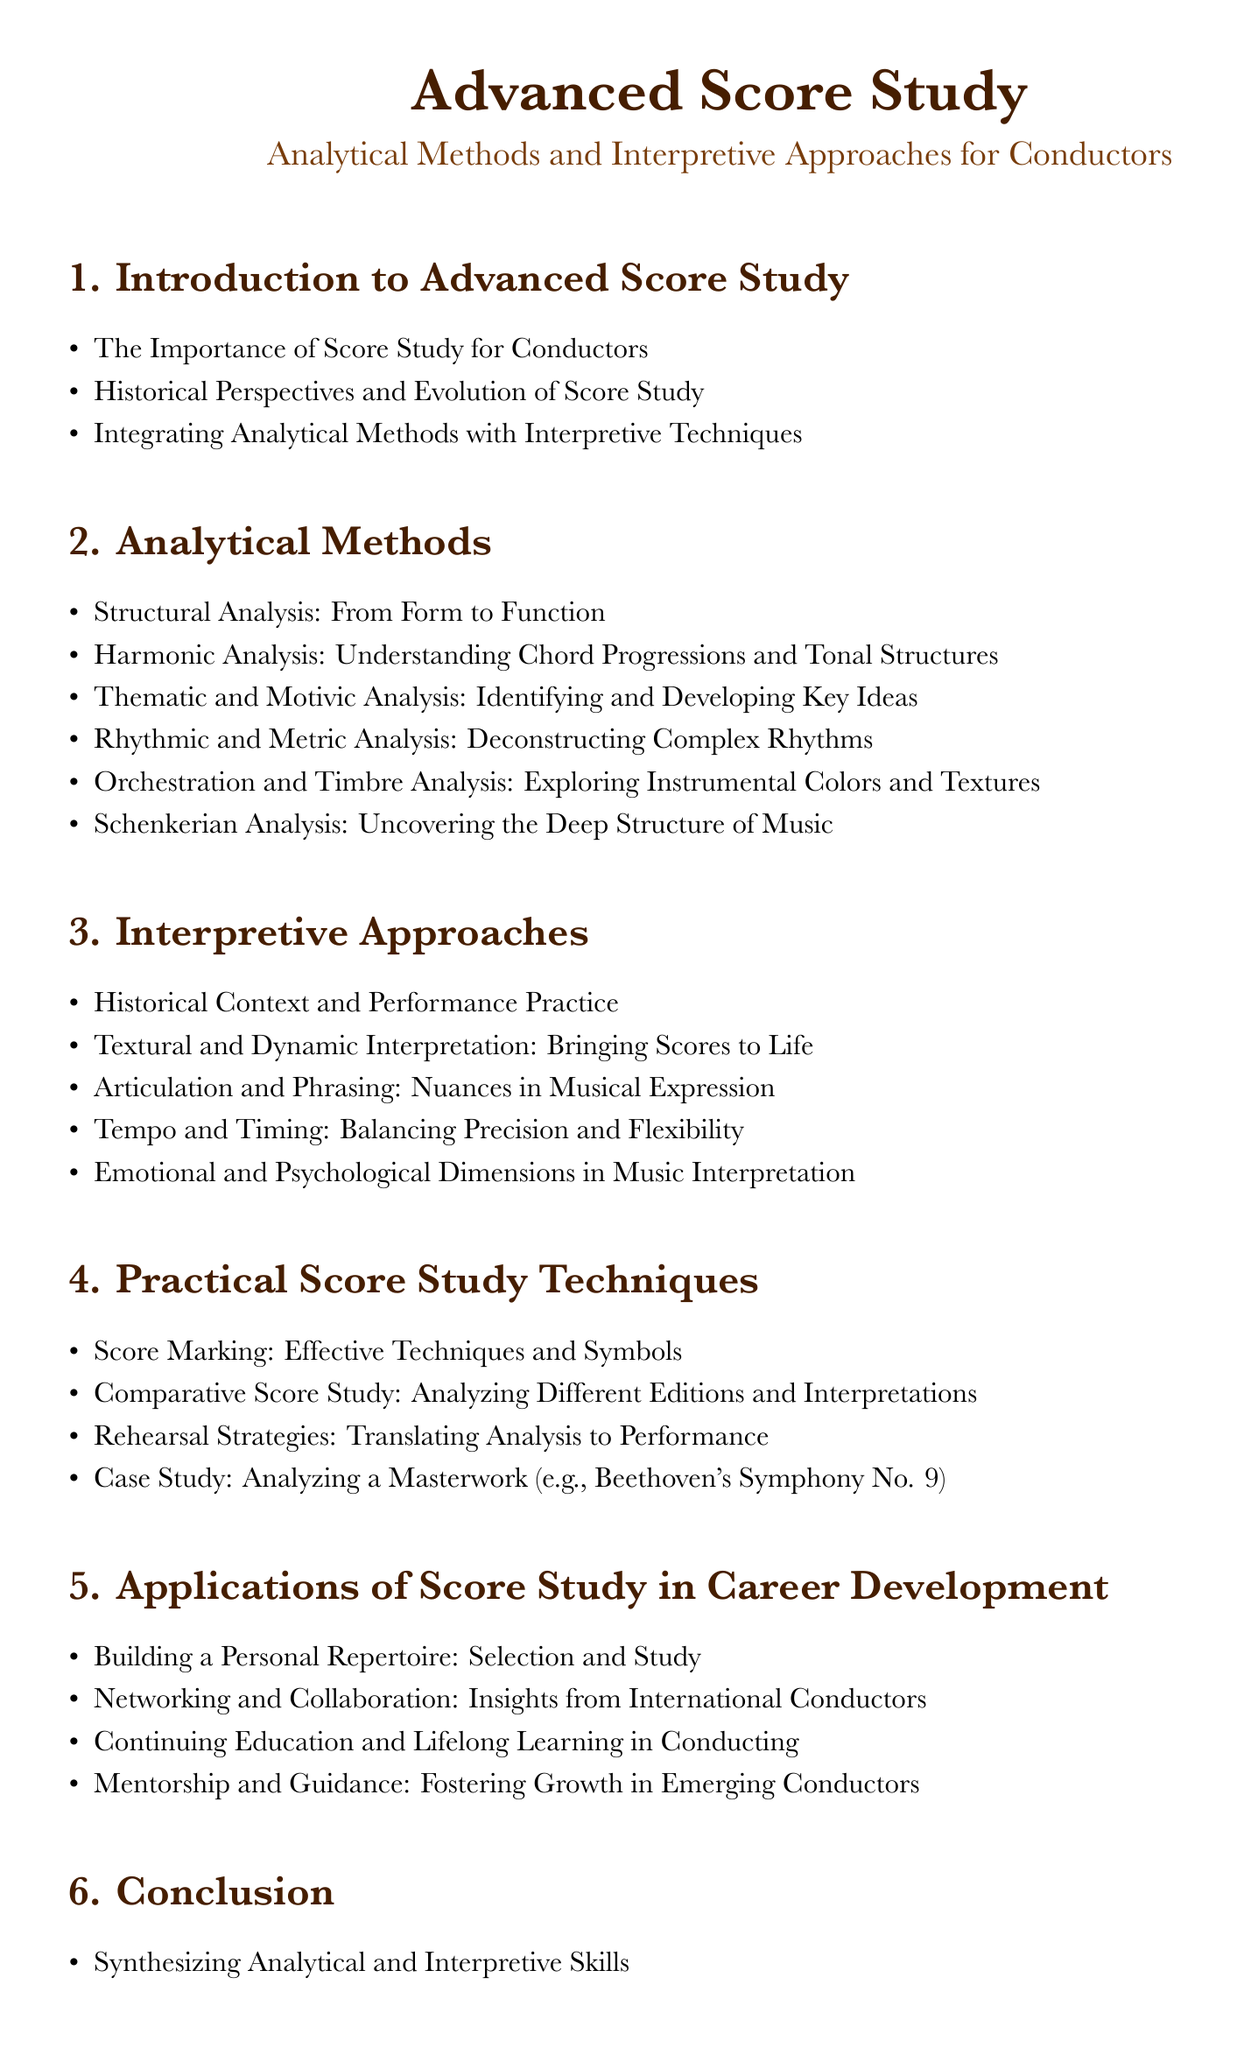What is the first section of the document? The first section listed is "Introduction to Advanced Score Study".
Answer: Introduction to Advanced Score Study How many analytical methods are listed? There are six methods outlined in the "Analytical Methods" section.
Answer: Six What is one topic covered under Practical Score Study Techniques? The section includes "Score Marking: Effective Techniques and Symbols" as one of the topics.
Answer: Score Marking: Effective Techniques and Symbols What does the fifth section focus on? The fifth section deals with "Applications of Score Study in Career Development".
Answer: Applications of Score Study in Career Development Name one interpretive approach discussed. The document mentions "Historical Context and Performance Practice" as an interpretive approach.
Answer: Historical Context and Performance Practice What is the last topic in the conclusion section? The last topic listed in the conclusion is "Personal Reflections: The Journey of a Seasoned Conductor".
Answer: Personal Reflections: The Journey of a Seasoned Conductor How many subsections are there under "Interpretive Approaches"? There are five subsections under "Interpretive Approaches".
Answer: Five What type of analysis is specifically mentioned in "Analytical Methods"? "Schenkerian Analysis" is mentioned as a specific type of analysis.
Answer: Schenkerian Analysis 